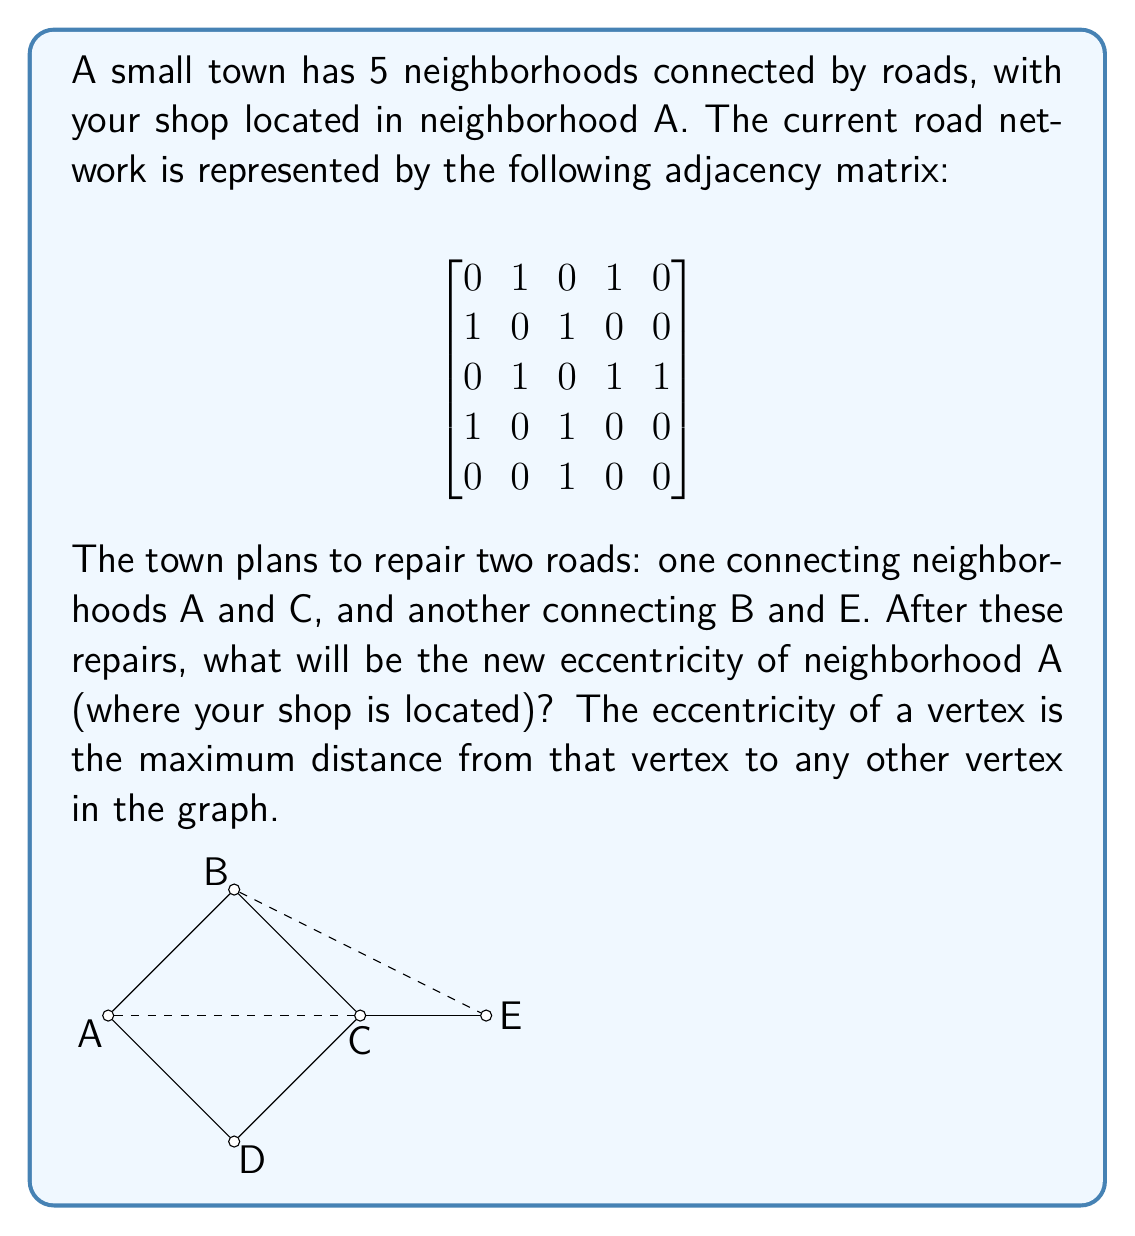Can you solve this math problem? To solve this problem, we need to follow these steps:

1) First, let's update the adjacency matrix with the new roads:

$$
\begin{bmatrix}
0 & 1 & 1 & 1 & 0 \\
1 & 0 & 1 & 0 & 1 \\
1 & 1 & 0 & 1 & 1 \\
1 & 0 & 1 & 0 & 0 \\
0 & 1 & 1 & 0 & 0
\end{bmatrix}
$$

2) Now, we need to calculate the distances from A to all other neighborhoods. We can use breadth-first search (BFS) or simply observe the graph:

   - A to B: 1 step
   - A to C: 1 step (new direct connection)
   - A to D: 1 step
   - A to E: 2 steps (either A-C-E or A-B-E)

3) The eccentricity of A is the maximum of these distances.

4) Therefore, the new eccentricity of A is 2.

This result shows that after the road repairs, your shop in neighborhood A will be at most 2 steps away from any other neighborhood, improving overall connectivity and potentially attracting more customers from all parts of the town.
Answer: The new eccentricity of neighborhood A after the proposed road repairs is 2. 